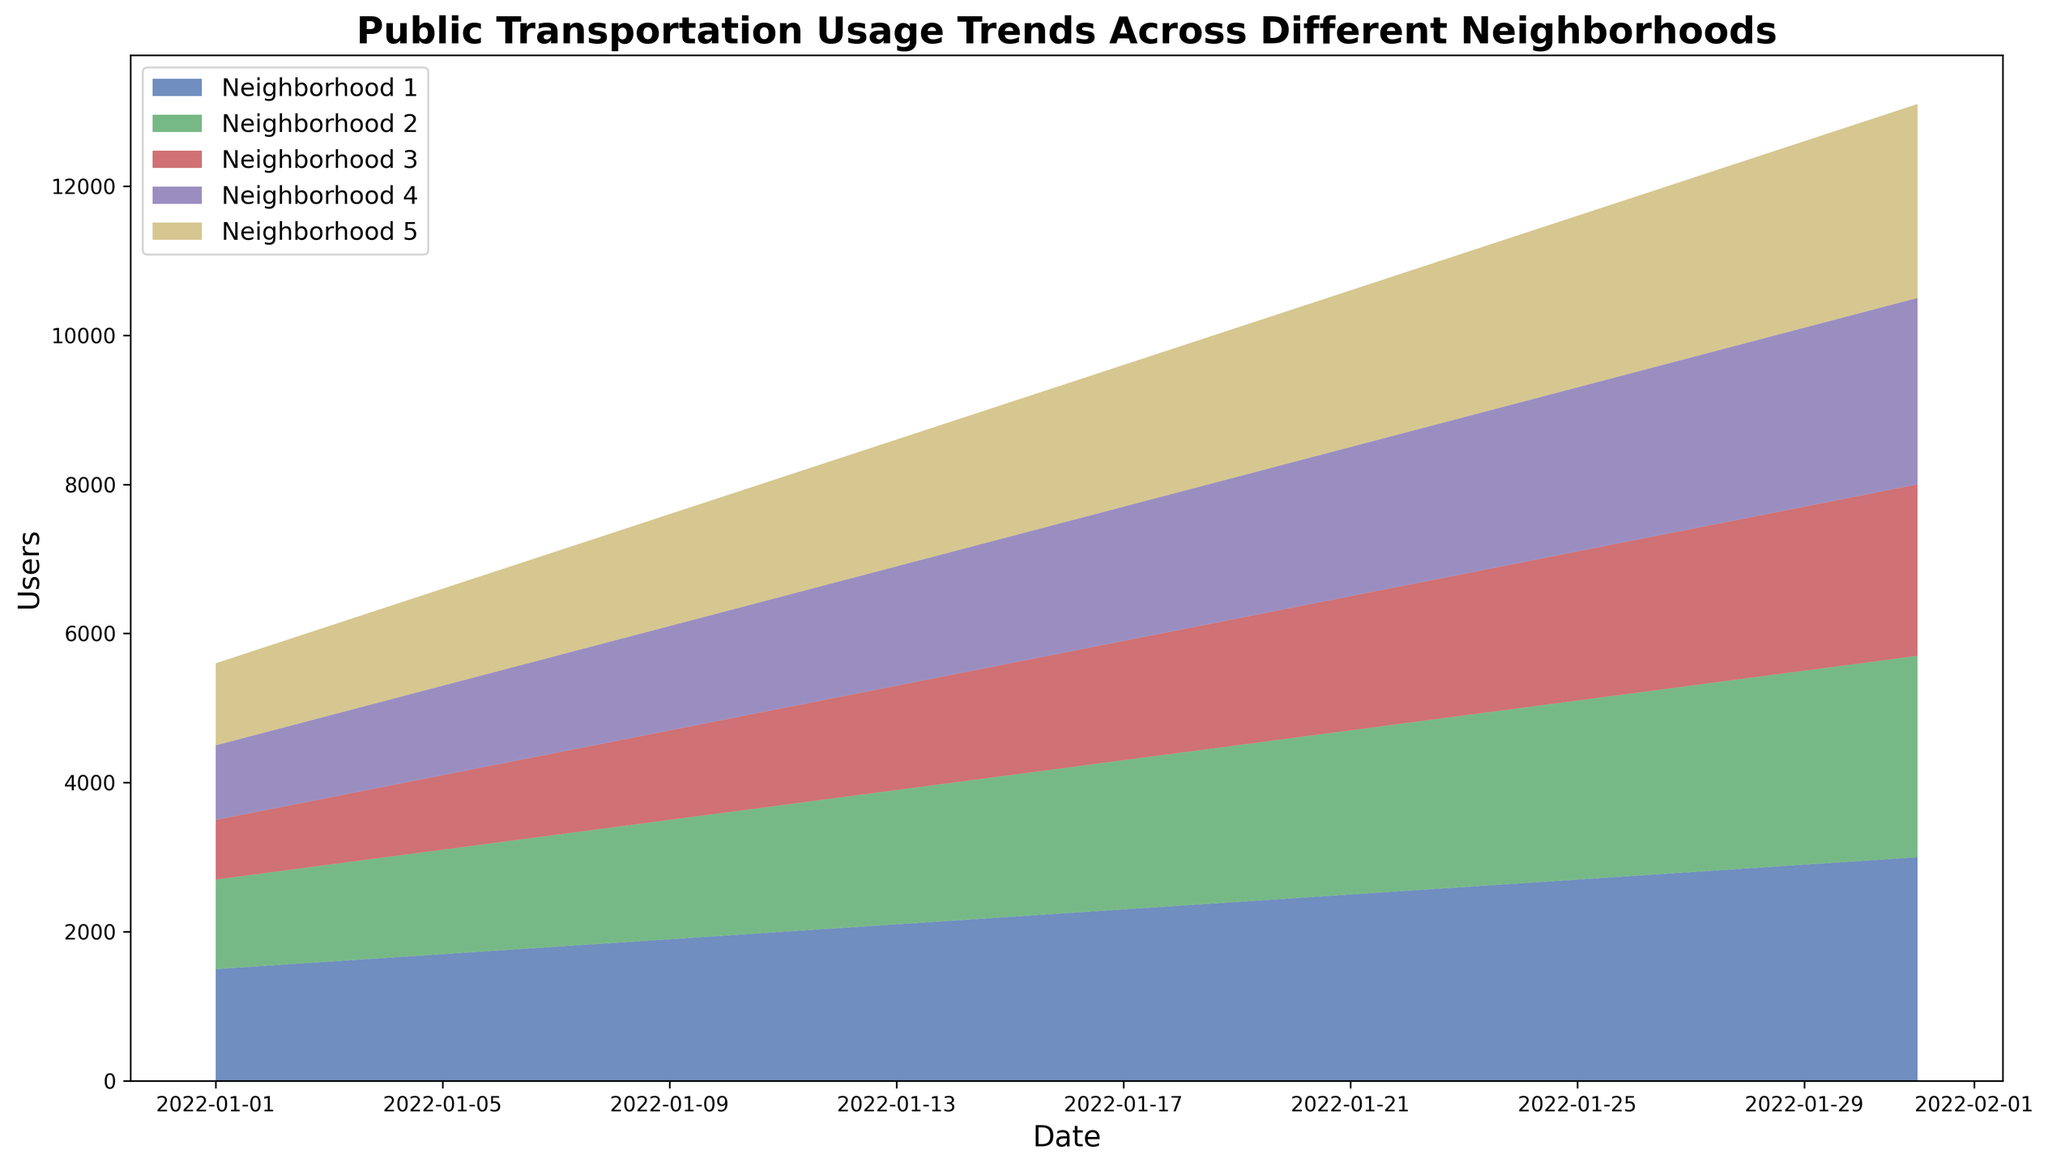What's the average number of public transportation users on January 10th across all neighborhoods? Look at the value for each neighborhood on January 10th: Neighborhood 1 (1950), Neighborhood 2 (1650), Neighborhood 3 (1250), Neighborhood 4 (1450), Neighborhood 5 (1550). Sum these values (1950 + 1650 + 1250 + 1450 + 1550 = 7850) and divide by the number of neighborhoods (5). So, 7850 / 5 = 1570.
Answer: 1570 Which neighborhood had the highest increase in public transportation usage from January 1st to January 31st? Compare the increase in users for each neighborhood by calculating the difference between the values on January 31st and January 1st. Neighborhood 1: 3000 - 1500 = 1500; Neighborhood 2: 2700 - 1200 = 1500; Neighborhood 3: 2300 - 800 = 1500; Neighborhood 4: 2500 - 1000 = 1500; Neighborhood 5: 2600 - 1100 = 1500. All neighborhoods had the same increase of 1500 users.
Answer: All neighborhoods On which date did Neighborhood 5 surpass 2000 users for the first time? Identify the date when Neighborhood 5's value exceeds 2000. January 20th shows 2050 users for Neighborhood 5. This is the first occurrence.
Answer: January 20th Which neighborhood has the most consistent increase in public transportation usage over the observed period? Observe the slope or steepness of the lines representing each neighborhood. Neighborhood 1 has a steadily increasing slope without major fluctuations, similar to other neighborhoods but with more noticeable consistency in increments.
Answer: Neighborhood 1 How does the total public transportation usage trend over time? Sum the values of all neighborhoods for a few key dates to see the general trend. For example, sum the users on January 1st (1500+1200+800+1000+1100 = 5600) and January 31st (3000+2700+2300+2500+2600 = 13100). The overall trend is increasing.
Answer: Increasing Which neighborhoods had a usership of over 2000 on January 20th? Check the values for January 20th. Neighborhood 1: 2450, Neighborhood 2: 2150, Neighborhood 3: 1750, Neighborhood 4: 1950, Neighborhood 5: 2050. Neighborhoods 1, 2, and 5 have usership over 2000.
Answer: Neighborhoods 1, 2, and 5 At what rate did public transportation usage increase in Neighborhood 3 from January 10th to January 20th? Calculate the difference in usership for Neighborhood 3 between the two dates (1750 - 1250 = 500) and divide by the number of days (10). So, 500 / 10 = 50 users per day.
Answer: 50 users/day Which neighborhood shows the most variation in public transportation usage from start to end of the month? Calculate the difference between January 1st and January 31st values for each neighborhood. All neighborhoods show the same variation (1500 users), so no single neighborhood stands out.
Answer: No single neighborhood stands out What's the combined public transportation usage on January 15th for Neighborhoods 2 and 4? Sum the values of Neighborhood 2 (1900) and Neighborhood 4 (1700) on January 15th. So, 1900 + 1700 = 3600.
Answer: 3600 On January 25th, which neighborhood had the second highest number of users? Compare the values for January 25th: Neighborhood 1 (2700), Neighborhood 2 (2400), Neighborhood 3 (2000), Neighborhood 4 (2200), Neighborhood 5 (2300). Neighborhood 2 has the second highest value.
Answer: Neighborhood 2 